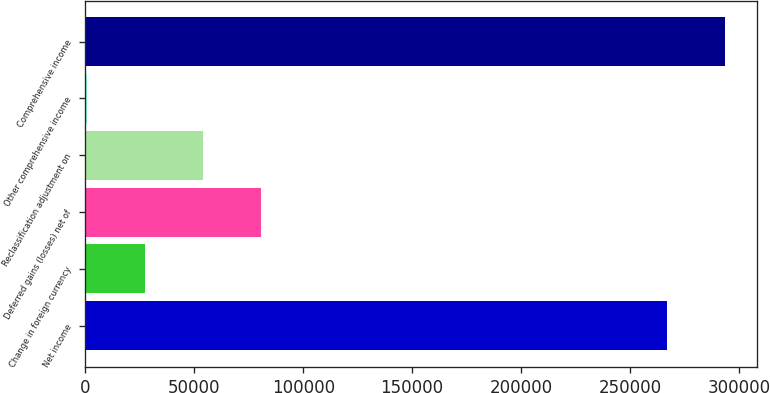Convert chart to OTSL. <chart><loc_0><loc_0><loc_500><loc_500><bar_chart><fcel>Net income<fcel>Change in foreign currency<fcel>Deferred gains (losses) net of<fcel>Reclassification adjustment on<fcel>Other comprehensive income<fcel>Comprehensive income<nl><fcel>266826<fcel>27480.6<fcel>80845.8<fcel>54163.2<fcel>798<fcel>293509<nl></chart> 